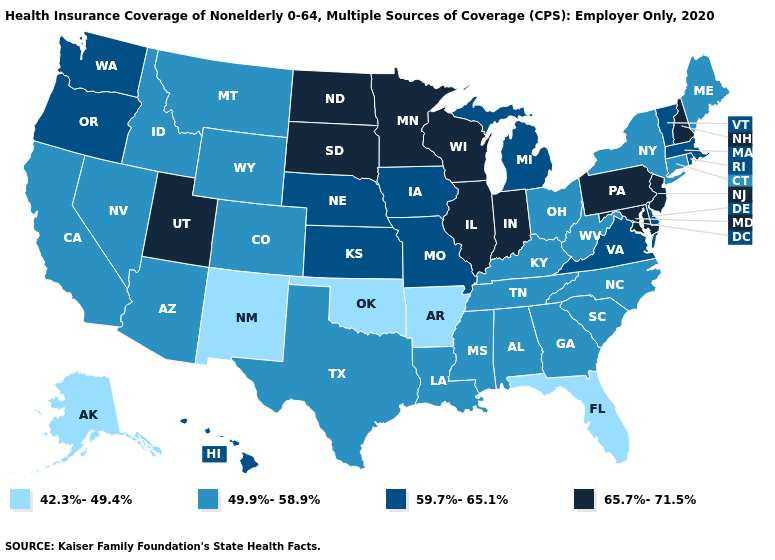What is the highest value in states that border Maine?
Be succinct. 65.7%-71.5%. Name the states that have a value in the range 49.9%-58.9%?
Quick response, please. Alabama, Arizona, California, Colorado, Connecticut, Georgia, Idaho, Kentucky, Louisiana, Maine, Mississippi, Montana, Nevada, New York, North Carolina, Ohio, South Carolina, Tennessee, Texas, West Virginia, Wyoming. What is the highest value in the West ?
Write a very short answer. 65.7%-71.5%. Name the states that have a value in the range 49.9%-58.9%?
Keep it brief. Alabama, Arizona, California, Colorado, Connecticut, Georgia, Idaho, Kentucky, Louisiana, Maine, Mississippi, Montana, Nevada, New York, North Carolina, Ohio, South Carolina, Tennessee, Texas, West Virginia, Wyoming. Among the states that border Missouri , which have the lowest value?
Write a very short answer. Arkansas, Oklahoma. What is the value of Colorado?
Quick response, please. 49.9%-58.9%. Does Nebraska have the lowest value in the USA?
Give a very brief answer. No. How many symbols are there in the legend?
Answer briefly. 4. What is the highest value in the Northeast ?
Answer briefly. 65.7%-71.5%. Among the states that border Missouri , does Arkansas have the lowest value?
Quick response, please. Yes. What is the value of Utah?
Answer briefly. 65.7%-71.5%. Name the states that have a value in the range 59.7%-65.1%?
Concise answer only. Delaware, Hawaii, Iowa, Kansas, Massachusetts, Michigan, Missouri, Nebraska, Oregon, Rhode Island, Vermont, Virginia, Washington. Does Washington have the lowest value in the USA?
Short answer required. No. 